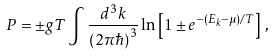<formula> <loc_0><loc_0><loc_500><loc_500>P = \pm g T \int \frac { d ^ { 3 } k } { ( 2 \pi \hbar { ) } ^ { 3 } } \ln \left [ 1 \pm e ^ { - ( E _ { k } - \mu ) / T } \right ] \, ,</formula> 